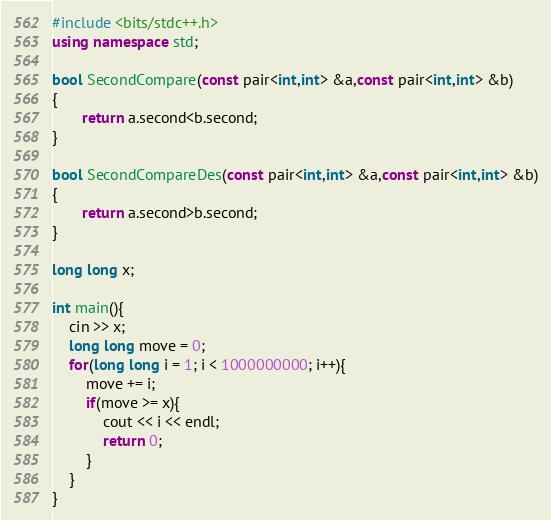Convert code to text. <code><loc_0><loc_0><loc_500><loc_500><_C++_>#include <bits/stdc++.h>
using namespace std;

bool SecondCompare(const pair<int,int> &a,const pair<int,int> &b)
{
       return a.second<b.second;
}

bool SecondCompareDes(const pair<int,int> &a,const pair<int,int> &b)
{
       return a.second>b.second;
}

long long x;

int main(){
    cin >> x;
    long long move = 0;
    for(long long i = 1; i < 1000000000; i++){
        move += i;
        if(move >= x){
            cout << i << endl;
            return 0;
        }
    }
}</code> 